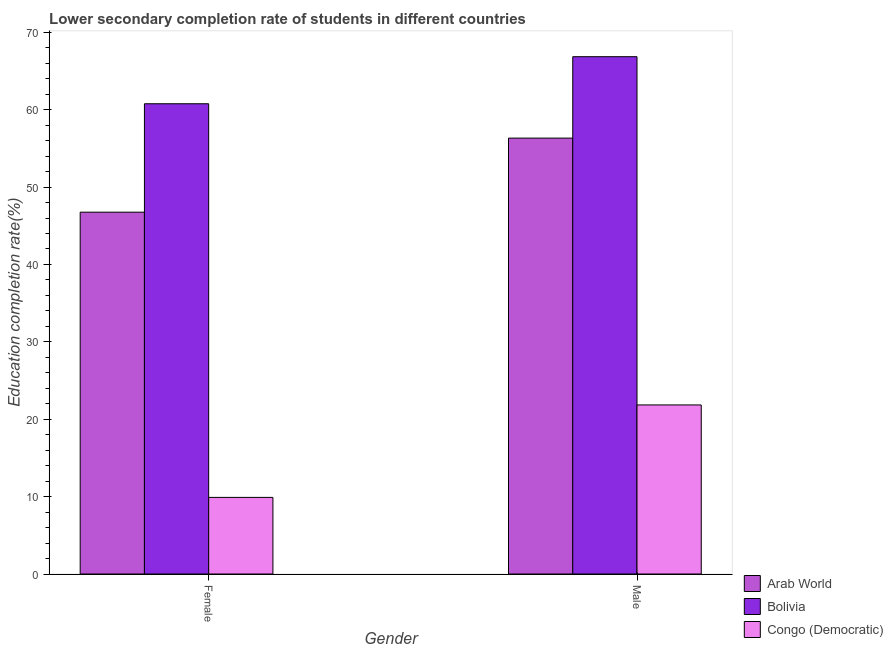How many bars are there on the 1st tick from the right?
Ensure brevity in your answer.  3. What is the label of the 2nd group of bars from the left?
Make the answer very short. Male. What is the education completion rate of female students in Arab World?
Offer a terse response. 46.75. Across all countries, what is the maximum education completion rate of female students?
Your response must be concise. 60.76. Across all countries, what is the minimum education completion rate of female students?
Ensure brevity in your answer.  9.9. In which country was the education completion rate of female students minimum?
Make the answer very short. Congo (Democratic). What is the total education completion rate of male students in the graph?
Make the answer very short. 145.01. What is the difference between the education completion rate of male students in Congo (Democratic) and that in Arab World?
Ensure brevity in your answer.  -34.48. What is the difference between the education completion rate of female students in Bolivia and the education completion rate of male students in Arab World?
Provide a short and direct response. 4.44. What is the average education completion rate of female students per country?
Offer a terse response. 39.14. What is the difference between the education completion rate of male students and education completion rate of female students in Arab World?
Keep it short and to the point. 9.57. What is the ratio of the education completion rate of female students in Congo (Democratic) to that in Arab World?
Your response must be concise. 0.21. What does the 2nd bar from the left in Female represents?
Offer a very short reply. Bolivia. What does the 1st bar from the right in Male represents?
Your answer should be very brief. Congo (Democratic). What is the difference between two consecutive major ticks on the Y-axis?
Keep it short and to the point. 10. Are the values on the major ticks of Y-axis written in scientific E-notation?
Provide a succinct answer. No. Where does the legend appear in the graph?
Your answer should be compact. Bottom right. How many legend labels are there?
Your response must be concise. 3. What is the title of the graph?
Make the answer very short. Lower secondary completion rate of students in different countries. Does "Argentina" appear as one of the legend labels in the graph?
Offer a terse response. No. What is the label or title of the Y-axis?
Give a very brief answer. Education completion rate(%). What is the Education completion rate(%) of Arab World in Female?
Give a very brief answer. 46.75. What is the Education completion rate(%) of Bolivia in Female?
Your response must be concise. 60.76. What is the Education completion rate(%) in Congo (Democratic) in Female?
Your response must be concise. 9.9. What is the Education completion rate(%) in Arab World in Male?
Provide a short and direct response. 56.32. What is the Education completion rate(%) of Bolivia in Male?
Give a very brief answer. 66.85. What is the Education completion rate(%) of Congo (Democratic) in Male?
Your answer should be compact. 21.85. Across all Gender, what is the maximum Education completion rate(%) in Arab World?
Ensure brevity in your answer.  56.32. Across all Gender, what is the maximum Education completion rate(%) of Bolivia?
Provide a short and direct response. 66.85. Across all Gender, what is the maximum Education completion rate(%) of Congo (Democratic)?
Provide a short and direct response. 21.85. Across all Gender, what is the minimum Education completion rate(%) in Arab World?
Provide a short and direct response. 46.75. Across all Gender, what is the minimum Education completion rate(%) of Bolivia?
Provide a succinct answer. 60.76. Across all Gender, what is the minimum Education completion rate(%) in Congo (Democratic)?
Make the answer very short. 9.9. What is the total Education completion rate(%) of Arab World in the graph?
Provide a short and direct response. 103.08. What is the total Education completion rate(%) in Bolivia in the graph?
Keep it short and to the point. 127.61. What is the total Education completion rate(%) in Congo (Democratic) in the graph?
Offer a very short reply. 31.74. What is the difference between the Education completion rate(%) in Arab World in Female and that in Male?
Give a very brief answer. -9.57. What is the difference between the Education completion rate(%) of Bolivia in Female and that in Male?
Offer a terse response. -6.08. What is the difference between the Education completion rate(%) of Congo (Democratic) in Female and that in Male?
Your response must be concise. -11.95. What is the difference between the Education completion rate(%) in Arab World in Female and the Education completion rate(%) in Bolivia in Male?
Keep it short and to the point. -20.09. What is the difference between the Education completion rate(%) in Arab World in Female and the Education completion rate(%) in Congo (Democratic) in Male?
Keep it short and to the point. 24.91. What is the difference between the Education completion rate(%) of Bolivia in Female and the Education completion rate(%) of Congo (Democratic) in Male?
Ensure brevity in your answer.  38.92. What is the average Education completion rate(%) of Arab World per Gender?
Your answer should be very brief. 51.54. What is the average Education completion rate(%) of Bolivia per Gender?
Keep it short and to the point. 63.8. What is the average Education completion rate(%) in Congo (Democratic) per Gender?
Your answer should be compact. 15.87. What is the difference between the Education completion rate(%) of Arab World and Education completion rate(%) of Bolivia in Female?
Ensure brevity in your answer.  -14.01. What is the difference between the Education completion rate(%) in Arab World and Education completion rate(%) in Congo (Democratic) in Female?
Ensure brevity in your answer.  36.86. What is the difference between the Education completion rate(%) of Bolivia and Education completion rate(%) of Congo (Democratic) in Female?
Make the answer very short. 50.86. What is the difference between the Education completion rate(%) of Arab World and Education completion rate(%) of Bolivia in Male?
Make the answer very short. -10.52. What is the difference between the Education completion rate(%) of Arab World and Education completion rate(%) of Congo (Democratic) in Male?
Give a very brief answer. 34.48. What is the ratio of the Education completion rate(%) in Arab World in Female to that in Male?
Offer a very short reply. 0.83. What is the ratio of the Education completion rate(%) of Bolivia in Female to that in Male?
Make the answer very short. 0.91. What is the ratio of the Education completion rate(%) of Congo (Democratic) in Female to that in Male?
Make the answer very short. 0.45. What is the difference between the highest and the second highest Education completion rate(%) in Arab World?
Provide a short and direct response. 9.57. What is the difference between the highest and the second highest Education completion rate(%) in Bolivia?
Offer a terse response. 6.08. What is the difference between the highest and the second highest Education completion rate(%) in Congo (Democratic)?
Provide a short and direct response. 11.95. What is the difference between the highest and the lowest Education completion rate(%) of Arab World?
Provide a succinct answer. 9.57. What is the difference between the highest and the lowest Education completion rate(%) of Bolivia?
Your answer should be very brief. 6.08. What is the difference between the highest and the lowest Education completion rate(%) of Congo (Democratic)?
Offer a terse response. 11.95. 